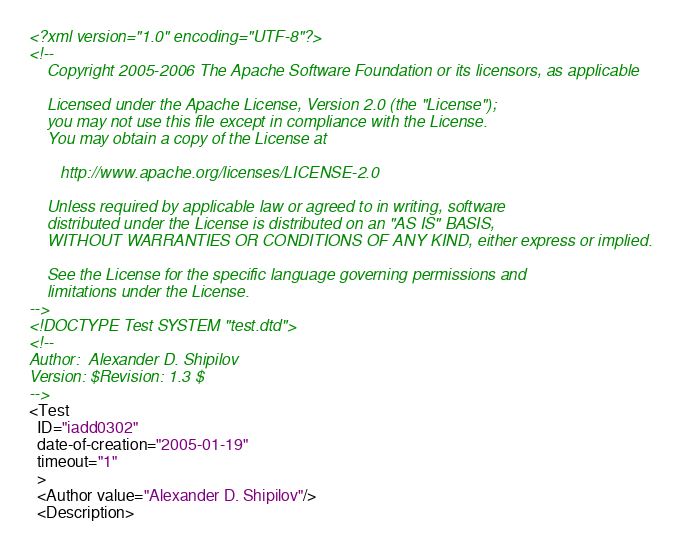<code> <loc_0><loc_0><loc_500><loc_500><_XML_><?xml version="1.0" encoding="UTF-8"?>
<!--
    Copyright 2005-2006 The Apache Software Foundation or its licensors, as applicable

    Licensed under the Apache License, Version 2.0 (the "License");
    you may not use this file except in compliance with the License.
    You may obtain a copy of the License at

       http://www.apache.org/licenses/LICENSE-2.0

    Unless required by applicable law or agreed to in writing, software
    distributed under the License is distributed on an "AS IS" BASIS,
    WITHOUT WARRANTIES OR CONDITIONS OF ANY KIND, either express or implied.

    See the License for the specific language governing permissions and
    limitations under the License.
-->
<!DOCTYPE Test SYSTEM "test.dtd">
<!--
Author:  Alexander D. Shipilov
Version: $Revision: 1.3 $
-->
<Test
  ID="iadd0302"
  date-of-creation="2005-01-19"
  timeout="1"
  >
  <Author value="Alexander D. Shipilov"/>
  <Description></code> 